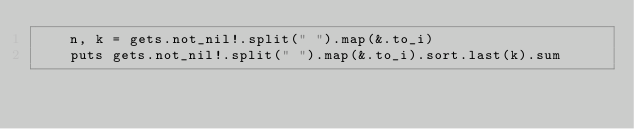Convert code to text. <code><loc_0><loc_0><loc_500><loc_500><_Crystal_>    n, k = gets.not_nil!.split(" ").map(&.to_i)
    puts gets.not_nil!.split(" ").map(&.to_i).sort.last(k).sum</code> 